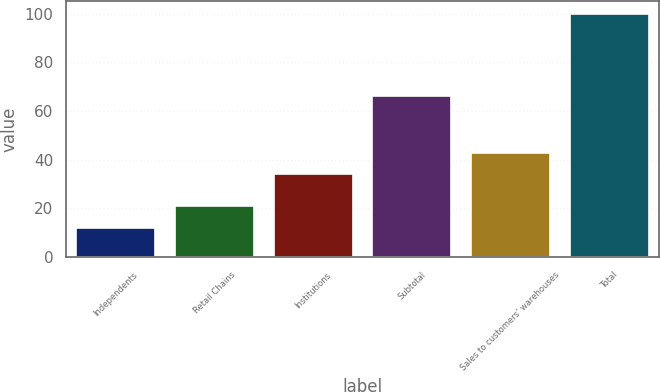<chart> <loc_0><loc_0><loc_500><loc_500><bar_chart><fcel>Independents<fcel>Retail Chains<fcel>Institutions<fcel>Subtotal<fcel>Sales to customers' warehouses<fcel>Total<nl><fcel>12<fcel>20.8<fcel>34<fcel>66<fcel>42.8<fcel>100<nl></chart> 